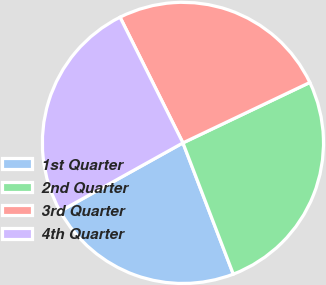Convert chart. <chart><loc_0><loc_0><loc_500><loc_500><pie_chart><fcel>1st Quarter<fcel>2nd Quarter<fcel>3rd Quarter<fcel>4th Quarter<nl><fcel>22.75%<fcel>26.24%<fcel>25.31%<fcel>25.7%<nl></chart> 